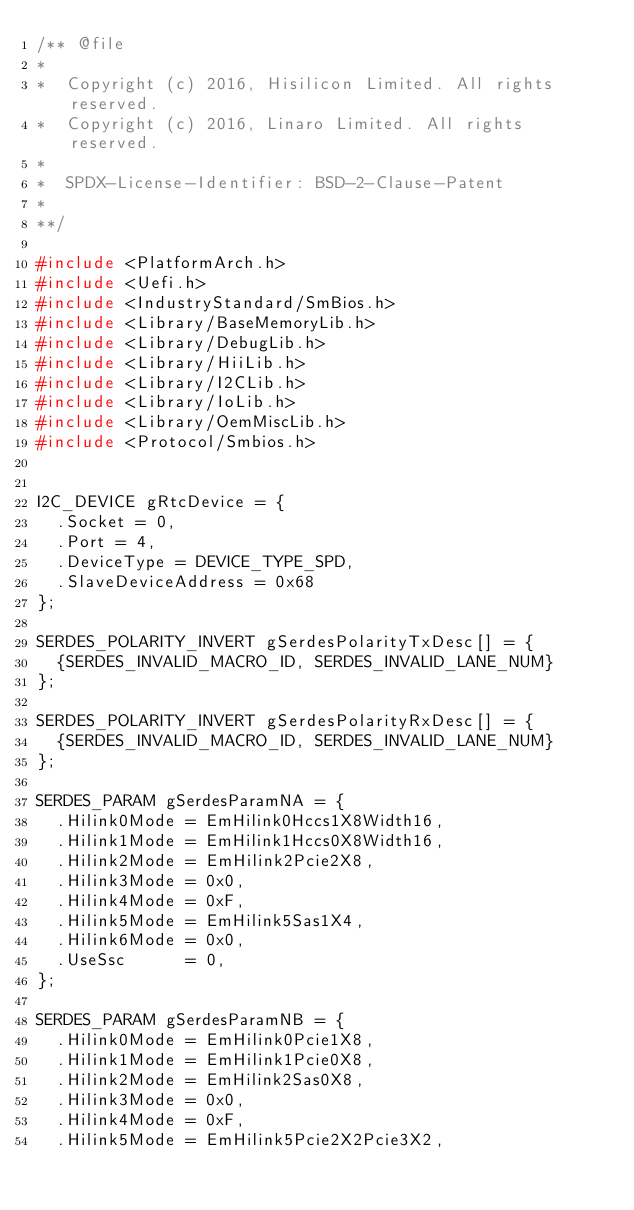Convert code to text. <code><loc_0><loc_0><loc_500><loc_500><_C_>/** @file
*
*  Copyright (c) 2016, Hisilicon Limited. All rights reserved.
*  Copyright (c) 2016, Linaro Limited. All rights reserved.
*
*  SPDX-License-Identifier: BSD-2-Clause-Patent
*
**/

#include <PlatformArch.h>
#include <Uefi.h>
#include <IndustryStandard/SmBios.h>
#include <Library/BaseMemoryLib.h>
#include <Library/DebugLib.h>
#include <Library/HiiLib.h>
#include <Library/I2CLib.h>
#include <Library/IoLib.h>
#include <Library/OemMiscLib.h>
#include <Protocol/Smbios.h>


I2C_DEVICE gRtcDevice = {
  .Socket = 0,
  .Port = 4,
  .DeviceType = DEVICE_TYPE_SPD,
  .SlaveDeviceAddress = 0x68
};

SERDES_POLARITY_INVERT gSerdesPolarityTxDesc[] = {
  {SERDES_INVALID_MACRO_ID, SERDES_INVALID_LANE_NUM}
};

SERDES_POLARITY_INVERT gSerdesPolarityRxDesc[] = {
  {SERDES_INVALID_MACRO_ID, SERDES_INVALID_LANE_NUM}
};

SERDES_PARAM gSerdesParamNA = {
  .Hilink0Mode = EmHilink0Hccs1X8Width16,
  .Hilink1Mode = EmHilink1Hccs0X8Width16,
  .Hilink2Mode = EmHilink2Pcie2X8,
  .Hilink3Mode = 0x0,
  .Hilink4Mode = 0xF,
  .Hilink5Mode = EmHilink5Sas1X4,
  .Hilink6Mode = 0x0,
  .UseSsc      = 0,
};

SERDES_PARAM gSerdesParamNB = {
  .Hilink0Mode = EmHilink0Pcie1X8,
  .Hilink1Mode = EmHilink1Pcie0X8,
  .Hilink2Mode = EmHilink2Sas0X8,
  .Hilink3Mode = 0x0,
  .Hilink4Mode = 0xF,
  .Hilink5Mode = EmHilink5Pcie2X2Pcie3X2,</code> 